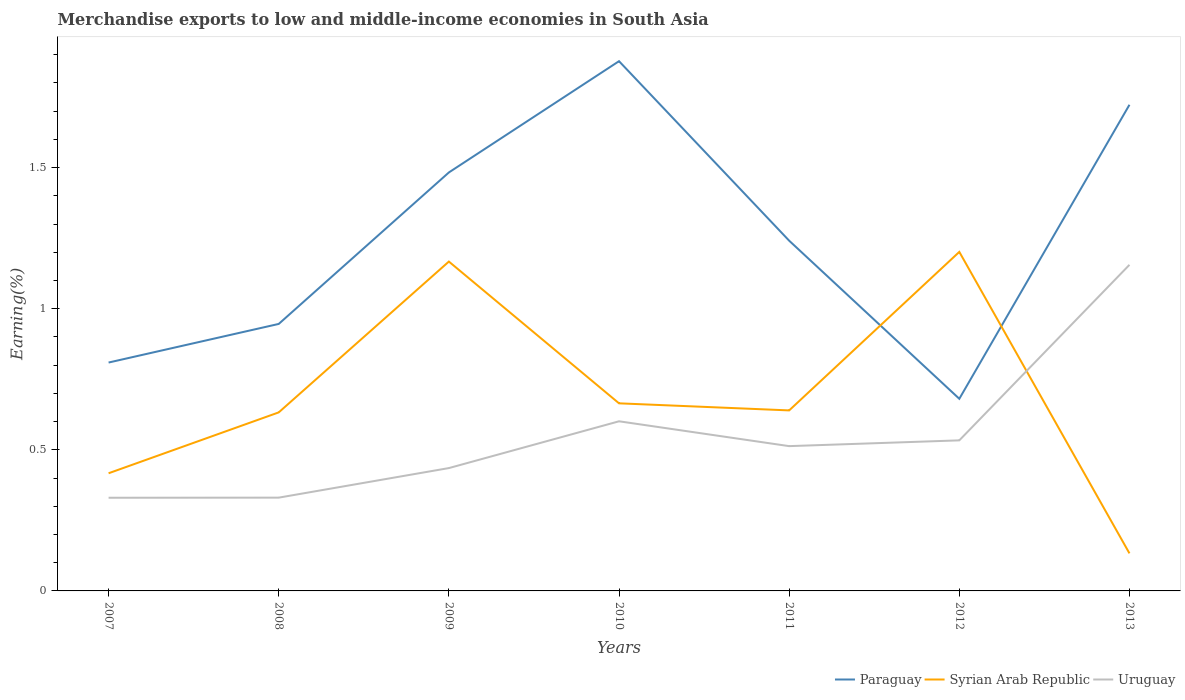Does the line corresponding to Uruguay intersect with the line corresponding to Paraguay?
Your answer should be very brief. No. Across all years, what is the maximum percentage of amount earned from merchandise exports in Syrian Arab Republic?
Your response must be concise. 0.13. What is the total percentage of amount earned from merchandise exports in Paraguay in the graph?
Offer a very short reply. 0.15. What is the difference between the highest and the second highest percentage of amount earned from merchandise exports in Syrian Arab Republic?
Provide a short and direct response. 1.07. What is the difference between the highest and the lowest percentage of amount earned from merchandise exports in Syrian Arab Republic?
Offer a very short reply. 2. How many lines are there?
Offer a terse response. 3. Are the values on the major ticks of Y-axis written in scientific E-notation?
Your answer should be very brief. No. Does the graph contain grids?
Give a very brief answer. No. Where does the legend appear in the graph?
Provide a succinct answer. Bottom right. What is the title of the graph?
Provide a short and direct response. Merchandise exports to low and middle-income economies in South Asia. What is the label or title of the Y-axis?
Give a very brief answer. Earning(%). What is the Earning(%) in Paraguay in 2007?
Your response must be concise. 0.81. What is the Earning(%) in Syrian Arab Republic in 2007?
Keep it short and to the point. 0.42. What is the Earning(%) in Uruguay in 2007?
Your response must be concise. 0.33. What is the Earning(%) of Paraguay in 2008?
Provide a short and direct response. 0.95. What is the Earning(%) in Syrian Arab Republic in 2008?
Your answer should be compact. 0.63. What is the Earning(%) of Uruguay in 2008?
Ensure brevity in your answer.  0.33. What is the Earning(%) of Paraguay in 2009?
Give a very brief answer. 1.48. What is the Earning(%) of Syrian Arab Republic in 2009?
Offer a terse response. 1.17. What is the Earning(%) of Uruguay in 2009?
Your response must be concise. 0.44. What is the Earning(%) of Paraguay in 2010?
Your response must be concise. 1.88. What is the Earning(%) of Syrian Arab Republic in 2010?
Provide a short and direct response. 0.66. What is the Earning(%) of Uruguay in 2010?
Your answer should be compact. 0.6. What is the Earning(%) in Paraguay in 2011?
Provide a short and direct response. 1.24. What is the Earning(%) of Syrian Arab Republic in 2011?
Your answer should be compact. 0.64. What is the Earning(%) in Uruguay in 2011?
Your response must be concise. 0.51. What is the Earning(%) of Paraguay in 2012?
Provide a succinct answer. 0.68. What is the Earning(%) of Syrian Arab Republic in 2012?
Offer a very short reply. 1.2. What is the Earning(%) in Uruguay in 2012?
Your response must be concise. 0.53. What is the Earning(%) of Paraguay in 2013?
Provide a succinct answer. 1.72. What is the Earning(%) in Syrian Arab Republic in 2013?
Your response must be concise. 0.13. What is the Earning(%) in Uruguay in 2013?
Give a very brief answer. 1.16. Across all years, what is the maximum Earning(%) in Paraguay?
Offer a very short reply. 1.88. Across all years, what is the maximum Earning(%) in Syrian Arab Republic?
Keep it short and to the point. 1.2. Across all years, what is the maximum Earning(%) of Uruguay?
Your answer should be compact. 1.16. Across all years, what is the minimum Earning(%) of Paraguay?
Provide a succinct answer. 0.68. Across all years, what is the minimum Earning(%) in Syrian Arab Republic?
Your answer should be compact. 0.13. Across all years, what is the minimum Earning(%) in Uruguay?
Your response must be concise. 0.33. What is the total Earning(%) of Paraguay in the graph?
Offer a terse response. 8.76. What is the total Earning(%) of Syrian Arab Republic in the graph?
Keep it short and to the point. 4.86. What is the total Earning(%) in Uruguay in the graph?
Your response must be concise. 3.9. What is the difference between the Earning(%) of Paraguay in 2007 and that in 2008?
Your response must be concise. -0.14. What is the difference between the Earning(%) of Syrian Arab Republic in 2007 and that in 2008?
Your response must be concise. -0.22. What is the difference between the Earning(%) in Uruguay in 2007 and that in 2008?
Your answer should be very brief. -0. What is the difference between the Earning(%) in Paraguay in 2007 and that in 2009?
Provide a succinct answer. -0.67. What is the difference between the Earning(%) of Syrian Arab Republic in 2007 and that in 2009?
Make the answer very short. -0.75. What is the difference between the Earning(%) of Uruguay in 2007 and that in 2009?
Your answer should be compact. -0.11. What is the difference between the Earning(%) in Paraguay in 2007 and that in 2010?
Provide a succinct answer. -1.07. What is the difference between the Earning(%) in Syrian Arab Republic in 2007 and that in 2010?
Give a very brief answer. -0.25. What is the difference between the Earning(%) of Uruguay in 2007 and that in 2010?
Your answer should be very brief. -0.27. What is the difference between the Earning(%) in Paraguay in 2007 and that in 2011?
Make the answer very short. -0.43. What is the difference between the Earning(%) in Syrian Arab Republic in 2007 and that in 2011?
Provide a short and direct response. -0.22. What is the difference between the Earning(%) of Uruguay in 2007 and that in 2011?
Provide a succinct answer. -0.18. What is the difference between the Earning(%) in Paraguay in 2007 and that in 2012?
Provide a short and direct response. 0.13. What is the difference between the Earning(%) in Syrian Arab Republic in 2007 and that in 2012?
Your response must be concise. -0.78. What is the difference between the Earning(%) in Uruguay in 2007 and that in 2012?
Provide a short and direct response. -0.2. What is the difference between the Earning(%) of Paraguay in 2007 and that in 2013?
Your answer should be compact. -0.91. What is the difference between the Earning(%) of Syrian Arab Republic in 2007 and that in 2013?
Provide a short and direct response. 0.28. What is the difference between the Earning(%) of Uruguay in 2007 and that in 2013?
Keep it short and to the point. -0.83. What is the difference between the Earning(%) in Paraguay in 2008 and that in 2009?
Make the answer very short. -0.54. What is the difference between the Earning(%) of Syrian Arab Republic in 2008 and that in 2009?
Your answer should be very brief. -0.53. What is the difference between the Earning(%) in Uruguay in 2008 and that in 2009?
Provide a succinct answer. -0.1. What is the difference between the Earning(%) of Paraguay in 2008 and that in 2010?
Your answer should be compact. -0.93. What is the difference between the Earning(%) in Syrian Arab Republic in 2008 and that in 2010?
Provide a short and direct response. -0.03. What is the difference between the Earning(%) in Uruguay in 2008 and that in 2010?
Your answer should be very brief. -0.27. What is the difference between the Earning(%) of Paraguay in 2008 and that in 2011?
Ensure brevity in your answer.  -0.29. What is the difference between the Earning(%) in Syrian Arab Republic in 2008 and that in 2011?
Provide a succinct answer. -0.01. What is the difference between the Earning(%) in Uruguay in 2008 and that in 2011?
Make the answer very short. -0.18. What is the difference between the Earning(%) in Paraguay in 2008 and that in 2012?
Your answer should be compact. 0.27. What is the difference between the Earning(%) of Syrian Arab Republic in 2008 and that in 2012?
Make the answer very short. -0.57. What is the difference between the Earning(%) of Uruguay in 2008 and that in 2012?
Offer a terse response. -0.2. What is the difference between the Earning(%) in Paraguay in 2008 and that in 2013?
Give a very brief answer. -0.78. What is the difference between the Earning(%) in Syrian Arab Republic in 2008 and that in 2013?
Your answer should be very brief. 0.5. What is the difference between the Earning(%) in Uruguay in 2008 and that in 2013?
Your response must be concise. -0.82. What is the difference between the Earning(%) of Paraguay in 2009 and that in 2010?
Your answer should be very brief. -0.39. What is the difference between the Earning(%) of Syrian Arab Republic in 2009 and that in 2010?
Provide a short and direct response. 0.5. What is the difference between the Earning(%) in Uruguay in 2009 and that in 2010?
Make the answer very short. -0.17. What is the difference between the Earning(%) in Paraguay in 2009 and that in 2011?
Offer a very short reply. 0.24. What is the difference between the Earning(%) in Syrian Arab Republic in 2009 and that in 2011?
Provide a short and direct response. 0.53. What is the difference between the Earning(%) of Uruguay in 2009 and that in 2011?
Provide a succinct answer. -0.08. What is the difference between the Earning(%) of Paraguay in 2009 and that in 2012?
Provide a short and direct response. 0.8. What is the difference between the Earning(%) in Syrian Arab Republic in 2009 and that in 2012?
Keep it short and to the point. -0.03. What is the difference between the Earning(%) in Uruguay in 2009 and that in 2012?
Your response must be concise. -0.1. What is the difference between the Earning(%) of Paraguay in 2009 and that in 2013?
Keep it short and to the point. -0.24. What is the difference between the Earning(%) of Syrian Arab Republic in 2009 and that in 2013?
Your answer should be very brief. 1.03. What is the difference between the Earning(%) in Uruguay in 2009 and that in 2013?
Make the answer very short. -0.72. What is the difference between the Earning(%) in Paraguay in 2010 and that in 2011?
Keep it short and to the point. 0.64. What is the difference between the Earning(%) of Syrian Arab Republic in 2010 and that in 2011?
Offer a terse response. 0.03. What is the difference between the Earning(%) of Uruguay in 2010 and that in 2011?
Your answer should be compact. 0.09. What is the difference between the Earning(%) of Paraguay in 2010 and that in 2012?
Give a very brief answer. 1.2. What is the difference between the Earning(%) of Syrian Arab Republic in 2010 and that in 2012?
Keep it short and to the point. -0.54. What is the difference between the Earning(%) in Uruguay in 2010 and that in 2012?
Your response must be concise. 0.07. What is the difference between the Earning(%) of Paraguay in 2010 and that in 2013?
Offer a very short reply. 0.15. What is the difference between the Earning(%) in Syrian Arab Republic in 2010 and that in 2013?
Give a very brief answer. 0.53. What is the difference between the Earning(%) of Uruguay in 2010 and that in 2013?
Keep it short and to the point. -0.55. What is the difference between the Earning(%) of Paraguay in 2011 and that in 2012?
Provide a succinct answer. 0.56. What is the difference between the Earning(%) in Syrian Arab Republic in 2011 and that in 2012?
Ensure brevity in your answer.  -0.56. What is the difference between the Earning(%) in Uruguay in 2011 and that in 2012?
Your response must be concise. -0.02. What is the difference between the Earning(%) of Paraguay in 2011 and that in 2013?
Your response must be concise. -0.48. What is the difference between the Earning(%) in Syrian Arab Republic in 2011 and that in 2013?
Ensure brevity in your answer.  0.51. What is the difference between the Earning(%) of Uruguay in 2011 and that in 2013?
Your response must be concise. -0.64. What is the difference between the Earning(%) of Paraguay in 2012 and that in 2013?
Give a very brief answer. -1.04. What is the difference between the Earning(%) in Syrian Arab Republic in 2012 and that in 2013?
Make the answer very short. 1.07. What is the difference between the Earning(%) of Uruguay in 2012 and that in 2013?
Give a very brief answer. -0.62. What is the difference between the Earning(%) in Paraguay in 2007 and the Earning(%) in Syrian Arab Republic in 2008?
Make the answer very short. 0.18. What is the difference between the Earning(%) of Paraguay in 2007 and the Earning(%) of Uruguay in 2008?
Provide a succinct answer. 0.48. What is the difference between the Earning(%) of Syrian Arab Republic in 2007 and the Earning(%) of Uruguay in 2008?
Offer a very short reply. 0.09. What is the difference between the Earning(%) in Paraguay in 2007 and the Earning(%) in Syrian Arab Republic in 2009?
Your answer should be compact. -0.36. What is the difference between the Earning(%) of Paraguay in 2007 and the Earning(%) of Uruguay in 2009?
Provide a short and direct response. 0.37. What is the difference between the Earning(%) of Syrian Arab Republic in 2007 and the Earning(%) of Uruguay in 2009?
Give a very brief answer. -0.02. What is the difference between the Earning(%) in Paraguay in 2007 and the Earning(%) in Syrian Arab Republic in 2010?
Offer a terse response. 0.14. What is the difference between the Earning(%) in Paraguay in 2007 and the Earning(%) in Uruguay in 2010?
Your answer should be compact. 0.21. What is the difference between the Earning(%) of Syrian Arab Republic in 2007 and the Earning(%) of Uruguay in 2010?
Offer a very short reply. -0.18. What is the difference between the Earning(%) in Paraguay in 2007 and the Earning(%) in Syrian Arab Republic in 2011?
Keep it short and to the point. 0.17. What is the difference between the Earning(%) in Paraguay in 2007 and the Earning(%) in Uruguay in 2011?
Make the answer very short. 0.3. What is the difference between the Earning(%) of Syrian Arab Republic in 2007 and the Earning(%) of Uruguay in 2011?
Make the answer very short. -0.1. What is the difference between the Earning(%) in Paraguay in 2007 and the Earning(%) in Syrian Arab Republic in 2012?
Offer a terse response. -0.39. What is the difference between the Earning(%) of Paraguay in 2007 and the Earning(%) of Uruguay in 2012?
Give a very brief answer. 0.28. What is the difference between the Earning(%) in Syrian Arab Republic in 2007 and the Earning(%) in Uruguay in 2012?
Your answer should be compact. -0.12. What is the difference between the Earning(%) in Paraguay in 2007 and the Earning(%) in Syrian Arab Republic in 2013?
Make the answer very short. 0.68. What is the difference between the Earning(%) of Paraguay in 2007 and the Earning(%) of Uruguay in 2013?
Give a very brief answer. -0.35. What is the difference between the Earning(%) of Syrian Arab Republic in 2007 and the Earning(%) of Uruguay in 2013?
Give a very brief answer. -0.74. What is the difference between the Earning(%) of Paraguay in 2008 and the Earning(%) of Syrian Arab Republic in 2009?
Provide a succinct answer. -0.22. What is the difference between the Earning(%) of Paraguay in 2008 and the Earning(%) of Uruguay in 2009?
Offer a very short reply. 0.51. What is the difference between the Earning(%) of Syrian Arab Republic in 2008 and the Earning(%) of Uruguay in 2009?
Provide a short and direct response. 0.2. What is the difference between the Earning(%) of Paraguay in 2008 and the Earning(%) of Syrian Arab Republic in 2010?
Ensure brevity in your answer.  0.28. What is the difference between the Earning(%) of Paraguay in 2008 and the Earning(%) of Uruguay in 2010?
Give a very brief answer. 0.34. What is the difference between the Earning(%) in Syrian Arab Republic in 2008 and the Earning(%) in Uruguay in 2010?
Keep it short and to the point. 0.03. What is the difference between the Earning(%) of Paraguay in 2008 and the Earning(%) of Syrian Arab Republic in 2011?
Make the answer very short. 0.31. What is the difference between the Earning(%) of Paraguay in 2008 and the Earning(%) of Uruguay in 2011?
Your answer should be very brief. 0.43. What is the difference between the Earning(%) of Syrian Arab Republic in 2008 and the Earning(%) of Uruguay in 2011?
Give a very brief answer. 0.12. What is the difference between the Earning(%) of Paraguay in 2008 and the Earning(%) of Syrian Arab Republic in 2012?
Keep it short and to the point. -0.26. What is the difference between the Earning(%) of Paraguay in 2008 and the Earning(%) of Uruguay in 2012?
Provide a succinct answer. 0.41. What is the difference between the Earning(%) of Syrian Arab Republic in 2008 and the Earning(%) of Uruguay in 2012?
Your answer should be compact. 0.1. What is the difference between the Earning(%) of Paraguay in 2008 and the Earning(%) of Syrian Arab Republic in 2013?
Keep it short and to the point. 0.81. What is the difference between the Earning(%) of Paraguay in 2008 and the Earning(%) of Uruguay in 2013?
Your answer should be very brief. -0.21. What is the difference between the Earning(%) of Syrian Arab Republic in 2008 and the Earning(%) of Uruguay in 2013?
Offer a terse response. -0.52. What is the difference between the Earning(%) of Paraguay in 2009 and the Earning(%) of Syrian Arab Republic in 2010?
Provide a succinct answer. 0.82. What is the difference between the Earning(%) of Paraguay in 2009 and the Earning(%) of Uruguay in 2010?
Your answer should be very brief. 0.88. What is the difference between the Earning(%) in Syrian Arab Republic in 2009 and the Earning(%) in Uruguay in 2010?
Keep it short and to the point. 0.57. What is the difference between the Earning(%) in Paraguay in 2009 and the Earning(%) in Syrian Arab Republic in 2011?
Offer a very short reply. 0.84. What is the difference between the Earning(%) in Paraguay in 2009 and the Earning(%) in Uruguay in 2011?
Give a very brief answer. 0.97. What is the difference between the Earning(%) in Syrian Arab Republic in 2009 and the Earning(%) in Uruguay in 2011?
Ensure brevity in your answer.  0.65. What is the difference between the Earning(%) of Paraguay in 2009 and the Earning(%) of Syrian Arab Republic in 2012?
Ensure brevity in your answer.  0.28. What is the difference between the Earning(%) of Paraguay in 2009 and the Earning(%) of Uruguay in 2012?
Make the answer very short. 0.95. What is the difference between the Earning(%) in Syrian Arab Republic in 2009 and the Earning(%) in Uruguay in 2012?
Provide a succinct answer. 0.63. What is the difference between the Earning(%) of Paraguay in 2009 and the Earning(%) of Syrian Arab Republic in 2013?
Ensure brevity in your answer.  1.35. What is the difference between the Earning(%) in Paraguay in 2009 and the Earning(%) in Uruguay in 2013?
Provide a short and direct response. 0.33. What is the difference between the Earning(%) in Syrian Arab Republic in 2009 and the Earning(%) in Uruguay in 2013?
Offer a terse response. 0.01. What is the difference between the Earning(%) of Paraguay in 2010 and the Earning(%) of Syrian Arab Republic in 2011?
Keep it short and to the point. 1.24. What is the difference between the Earning(%) in Paraguay in 2010 and the Earning(%) in Uruguay in 2011?
Offer a very short reply. 1.36. What is the difference between the Earning(%) in Syrian Arab Republic in 2010 and the Earning(%) in Uruguay in 2011?
Your answer should be compact. 0.15. What is the difference between the Earning(%) in Paraguay in 2010 and the Earning(%) in Syrian Arab Republic in 2012?
Make the answer very short. 0.68. What is the difference between the Earning(%) in Paraguay in 2010 and the Earning(%) in Uruguay in 2012?
Keep it short and to the point. 1.34. What is the difference between the Earning(%) of Syrian Arab Republic in 2010 and the Earning(%) of Uruguay in 2012?
Keep it short and to the point. 0.13. What is the difference between the Earning(%) of Paraguay in 2010 and the Earning(%) of Syrian Arab Republic in 2013?
Your answer should be compact. 1.74. What is the difference between the Earning(%) of Paraguay in 2010 and the Earning(%) of Uruguay in 2013?
Your answer should be very brief. 0.72. What is the difference between the Earning(%) in Syrian Arab Republic in 2010 and the Earning(%) in Uruguay in 2013?
Provide a short and direct response. -0.49. What is the difference between the Earning(%) in Paraguay in 2011 and the Earning(%) in Syrian Arab Republic in 2012?
Your answer should be compact. 0.04. What is the difference between the Earning(%) of Paraguay in 2011 and the Earning(%) of Uruguay in 2012?
Your answer should be compact. 0.71. What is the difference between the Earning(%) of Syrian Arab Republic in 2011 and the Earning(%) of Uruguay in 2012?
Keep it short and to the point. 0.11. What is the difference between the Earning(%) in Paraguay in 2011 and the Earning(%) in Syrian Arab Republic in 2013?
Give a very brief answer. 1.11. What is the difference between the Earning(%) of Paraguay in 2011 and the Earning(%) of Uruguay in 2013?
Make the answer very short. 0.09. What is the difference between the Earning(%) of Syrian Arab Republic in 2011 and the Earning(%) of Uruguay in 2013?
Your answer should be very brief. -0.52. What is the difference between the Earning(%) of Paraguay in 2012 and the Earning(%) of Syrian Arab Republic in 2013?
Your response must be concise. 0.55. What is the difference between the Earning(%) in Paraguay in 2012 and the Earning(%) in Uruguay in 2013?
Offer a terse response. -0.47. What is the difference between the Earning(%) of Syrian Arab Republic in 2012 and the Earning(%) of Uruguay in 2013?
Offer a very short reply. 0.05. What is the average Earning(%) of Paraguay per year?
Your answer should be very brief. 1.25. What is the average Earning(%) in Syrian Arab Republic per year?
Give a very brief answer. 0.69. What is the average Earning(%) of Uruguay per year?
Provide a succinct answer. 0.56. In the year 2007, what is the difference between the Earning(%) of Paraguay and Earning(%) of Syrian Arab Republic?
Make the answer very short. 0.39. In the year 2007, what is the difference between the Earning(%) in Paraguay and Earning(%) in Uruguay?
Your answer should be very brief. 0.48. In the year 2007, what is the difference between the Earning(%) of Syrian Arab Republic and Earning(%) of Uruguay?
Make the answer very short. 0.09. In the year 2008, what is the difference between the Earning(%) in Paraguay and Earning(%) in Syrian Arab Republic?
Your answer should be very brief. 0.31. In the year 2008, what is the difference between the Earning(%) of Paraguay and Earning(%) of Uruguay?
Offer a terse response. 0.62. In the year 2008, what is the difference between the Earning(%) of Syrian Arab Republic and Earning(%) of Uruguay?
Offer a very short reply. 0.3. In the year 2009, what is the difference between the Earning(%) of Paraguay and Earning(%) of Syrian Arab Republic?
Make the answer very short. 0.32. In the year 2009, what is the difference between the Earning(%) of Paraguay and Earning(%) of Uruguay?
Ensure brevity in your answer.  1.05. In the year 2009, what is the difference between the Earning(%) in Syrian Arab Republic and Earning(%) in Uruguay?
Provide a succinct answer. 0.73. In the year 2010, what is the difference between the Earning(%) of Paraguay and Earning(%) of Syrian Arab Republic?
Provide a short and direct response. 1.21. In the year 2010, what is the difference between the Earning(%) in Paraguay and Earning(%) in Uruguay?
Your response must be concise. 1.28. In the year 2010, what is the difference between the Earning(%) in Syrian Arab Republic and Earning(%) in Uruguay?
Offer a very short reply. 0.06. In the year 2011, what is the difference between the Earning(%) in Paraguay and Earning(%) in Syrian Arab Republic?
Ensure brevity in your answer.  0.6. In the year 2011, what is the difference between the Earning(%) of Paraguay and Earning(%) of Uruguay?
Provide a succinct answer. 0.73. In the year 2011, what is the difference between the Earning(%) of Syrian Arab Republic and Earning(%) of Uruguay?
Ensure brevity in your answer.  0.13. In the year 2012, what is the difference between the Earning(%) in Paraguay and Earning(%) in Syrian Arab Republic?
Offer a terse response. -0.52. In the year 2012, what is the difference between the Earning(%) of Paraguay and Earning(%) of Uruguay?
Your response must be concise. 0.15. In the year 2012, what is the difference between the Earning(%) in Syrian Arab Republic and Earning(%) in Uruguay?
Offer a terse response. 0.67. In the year 2013, what is the difference between the Earning(%) of Paraguay and Earning(%) of Syrian Arab Republic?
Give a very brief answer. 1.59. In the year 2013, what is the difference between the Earning(%) in Paraguay and Earning(%) in Uruguay?
Offer a very short reply. 0.57. In the year 2013, what is the difference between the Earning(%) in Syrian Arab Republic and Earning(%) in Uruguay?
Your answer should be very brief. -1.02. What is the ratio of the Earning(%) in Paraguay in 2007 to that in 2008?
Give a very brief answer. 0.86. What is the ratio of the Earning(%) in Syrian Arab Republic in 2007 to that in 2008?
Offer a terse response. 0.66. What is the ratio of the Earning(%) of Uruguay in 2007 to that in 2008?
Your answer should be compact. 1. What is the ratio of the Earning(%) of Paraguay in 2007 to that in 2009?
Ensure brevity in your answer.  0.55. What is the ratio of the Earning(%) of Syrian Arab Republic in 2007 to that in 2009?
Make the answer very short. 0.36. What is the ratio of the Earning(%) of Uruguay in 2007 to that in 2009?
Make the answer very short. 0.76. What is the ratio of the Earning(%) in Paraguay in 2007 to that in 2010?
Keep it short and to the point. 0.43. What is the ratio of the Earning(%) in Syrian Arab Republic in 2007 to that in 2010?
Make the answer very short. 0.63. What is the ratio of the Earning(%) of Uruguay in 2007 to that in 2010?
Your answer should be very brief. 0.55. What is the ratio of the Earning(%) of Paraguay in 2007 to that in 2011?
Offer a terse response. 0.65. What is the ratio of the Earning(%) in Syrian Arab Republic in 2007 to that in 2011?
Provide a short and direct response. 0.65. What is the ratio of the Earning(%) in Uruguay in 2007 to that in 2011?
Give a very brief answer. 0.64. What is the ratio of the Earning(%) of Paraguay in 2007 to that in 2012?
Provide a short and direct response. 1.19. What is the ratio of the Earning(%) of Syrian Arab Republic in 2007 to that in 2012?
Your answer should be very brief. 0.35. What is the ratio of the Earning(%) of Uruguay in 2007 to that in 2012?
Ensure brevity in your answer.  0.62. What is the ratio of the Earning(%) in Paraguay in 2007 to that in 2013?
Ensure brevity in your answer.  0.47. What is the ratio of the Earning(%) of Syrian Arab Republic in 2007 to that in 2013?
Ensure brevity in your answer.  3.13. What is the ratio of the Earning(%) of Uruguay in 2007 to that in 2013?
Provide a succinct answer. 0.29. What is the ratio of the Earning(%) in Paraguay in 2008 to that in 2009?
Offer a terse response. 0.64. What is the ratio of the Earning(%) in Syrian Arab Republic in 2008 to that in 2009?
Make the answer very short. 0.54. What is the ratio of the Earning(%) in Uruguay in 2008 to that in 2009?
Provide a succinct answer. 0.76. What is the ratio of the Earning(%) in Paraguay in 2008 to that in 2010?
Your answer should be very brief. 0.5. What is the ratio of the Earning(%) in Syrian Arab Republic in 2008 to that in 2010?
Make the answer very short. 0.95. What is the ratio of the Earning(%) of Uruguay in 2008 to that in 2010?
Offer a very short reply. 0.55. What is the ratio of the Earning(%) in Paraguay in 2008 to that in 2011?
Offer a very short reply. 0.76. What is the ratio of the Earning(%) in Syrian Arab Republic in 2008 to that in 2011?
Give a very brief answer. 0.99. What is the ratio of the Earning(%) of Uruguay in 2008 to that in 2011?
Ensure brevity in your answer.  0.64. What is the ratio of the Earning(%) of Paraguay in 2008 to that in 2012?
Your answer should be very brief. 1.39. What is the ratio of the Earning(%) in Syrian Arab Republic in 2008 to that in 2012?
Your answer should be compact. 0.53. What is the ratio of the Earning(%) of Uruguay in 2008 to that in 2012?
Your response must be concise. 0.62. What is the ratio of the Earning(%) of Paraguay in 2008 to that in 2013?
Your response must be concise. 0.55. What is the ratio of the Earning(%) in Syrian Arab Republic in 2008 to that in 2013?
Provide a succinct answer. 4.75. What is the ratio of the Earning(%) in Uruguay in 2008 to that in 2013?
Make the answer very short. 0.29. What is the ratio of the Earning(%) in Paraguay in 2009 to that in 2010?
Your answer should be very brief. 0.79. What is the ratio of the Earning(%) in Syrian Arab Republic in 2009 to that in 2010?
Offer a very short reply. 1.76. What is the ratio of the Earning(%) in Uruguay in 2009 to that in 2010?
Your answer should be compact. 0.72. What is the ratio of the Earning(%) of Paraguay in 2009 to that in 2011?
Make the answer very short. 1.19. What is the ratio of the Earning(%) in Syrian Arab Republic in 2009 to that in 2011?
Provide a short and direct response. 1.82. What is the ratio of the Earning(%) of Uruguay in 2009 to that in 2011?
Keep it short and to the point. 0.85. What is the ratio of the Earning(%) of Paraguay in 2009 to that in 2012?
Make the answer very short. 2.18. What is the ratio of the Earning(%) of Syrian Arab Republic in 2009 to that in 2012?
Your response must be concise. 0.97. What is the ratio of the Earning(%) of Uruguay in 2009 to that in 2012?
Give a very brief answer. 0.82. What is the ratio of the Earning(%) of Paraguay in 2009 to that in 2013?
Ensure brevity in your answer.  0.86. What is the ratio of the Earning(%) in Syrian Arab Republic in 2009 to that in 2013?
Offer a terse response. 8.77. What is the ratio of the Earning(%) of Uruguay in 2009 to that in 2013?
Your response must be concise. 0.38. What is the ratio of the Earning(%) of Paraguay in 2010 to that in 2011?
Provide a short and direct response. 1.51. What is the ratio of the Earning(%) of Syrian Arab Republic in 2010 to that in 2011?
Make the answer very short. 1.04. What is the ratio of the Earning(%) in Uruguay in 2010 to that in 2011?
Offer a terse response. 1.17. What is the ratio of the Earning(%) in Paraguay in 2010 to that in 2012?
Provide a short and direct response. 2.76. What is the ratio of the Earning(%) of Syrian Arab Republic in 2010 to that in 2012?
Your response must be concise. 0.55. What is the ratio of the Earning(%) in Uruguay in 2010 to that in 2012?
Your answer should be very brief. 1.13. What is the ratio of the Earning(%) in Paraguay in 2010 to that in 2013?
Keep it short and to the point. 1.09. What is the ratio of the Earning(%) of Syrian Arab Republic in 2010 to that in 2013?
Your answer should be very brief. 4.99. What is the ratio of the Earning(%) of Uruguay in 2010 to that in 2013?
Provide a succinct answer. 0.52. What is the ratio of the Earning(%) in Paraguay in 2011 to that in 2012?
Offer a very short reply. 1.82. What is the ratio of the Earning(%) in Syrian Arab Republic in 2011 to that in 2012?
Offer a terse response. 0.53. What is the ratio of the Earning(%) of Uruguay in 2011 to that in 2012?
Your answer should be compact. 0.96. What is the ratio of the Earning(%) in Paraguay in 2011 to that in 2013?
Your answer should be very brief. 0.72. What is the ratio of the Earning(%) of Syrian Arab Republic in 2011 to that in 2013?
Give a very brief answer. 4.81. What is the ratio of the Earning(%) of Uruguay in 2011 to that in 2013?
Ensure brevity in your answer.  0.44. What is the ratio of the Earning(%) in Paraguay in 2012 to that in 2013?
Provide a succinct answer. 0.4. What is the ratio of the Earning(%) in Syrian Arab Republic in 2012 to that in 2013?
Keep it short and to the point. 9.03. What is the ratio of the Earning(%) of Uruguay in 2012 to that in 2013?
Offer a very short reply. 0.46. What is the difference between the highest and the second highest Earning(%) in Paraguay?
Your response must be concise. 0.15. What is the difference between the highest and the second highest Earning(%) in Syrian Arab Republic?
Your answer should be very brief. 0.03. What is the difference between the highest and the second highest Earning(%) in Uruguay?
Make the answer very short. 0.55. What is the difference between the highest and the lowest Earning(%) of Paraguay?
Offer a terse response. 1.2. What is the difference between the highest and the lowest Earning(%) of Syrian Arab Republic?
Your answer should be very brief. 1.07. What is the difference between the highest and the lowest Earning(%) of Uruguay?
Make the answer very short. 0.83. 